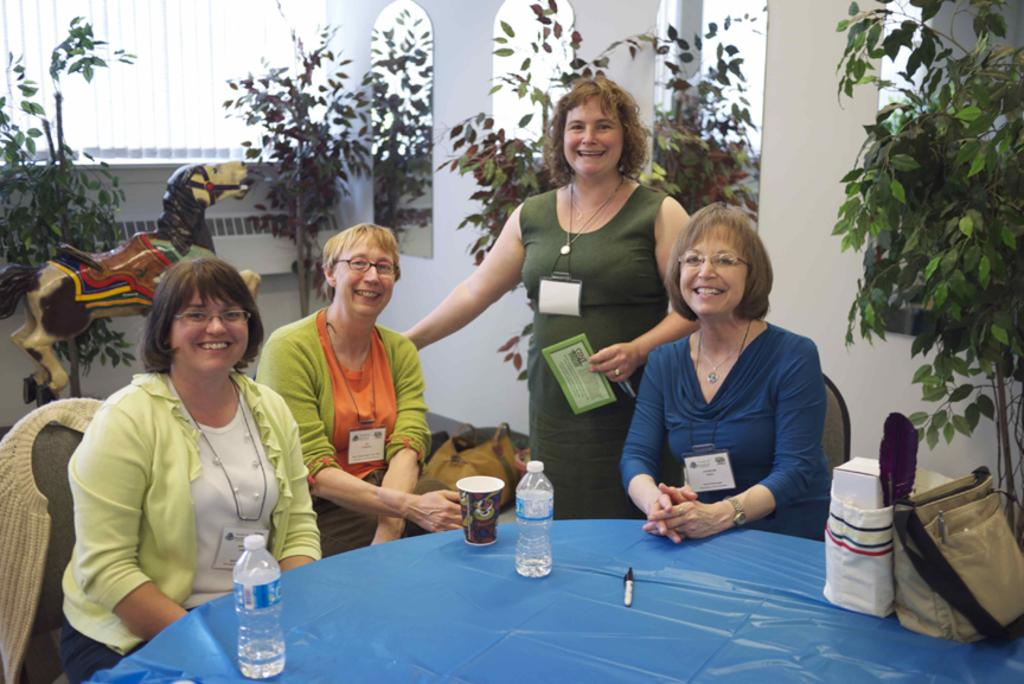What type of structure can be seen in the image? There is a wall in the image. What can be found growing in the image? There are plants in the image. What are the people in the image doing? The people are sitting on chairs in the image. What piece of furniture is present in the image? There is a table in the image. What items can be seen on the table? There is a handbag, bottles, and a cup on the table. Are there any dinosaurs visible in the image? No, there are no dinosaurs present in the image. What is the chance of winning a prize in the image? There is no mention of a prize or chance in the image. 